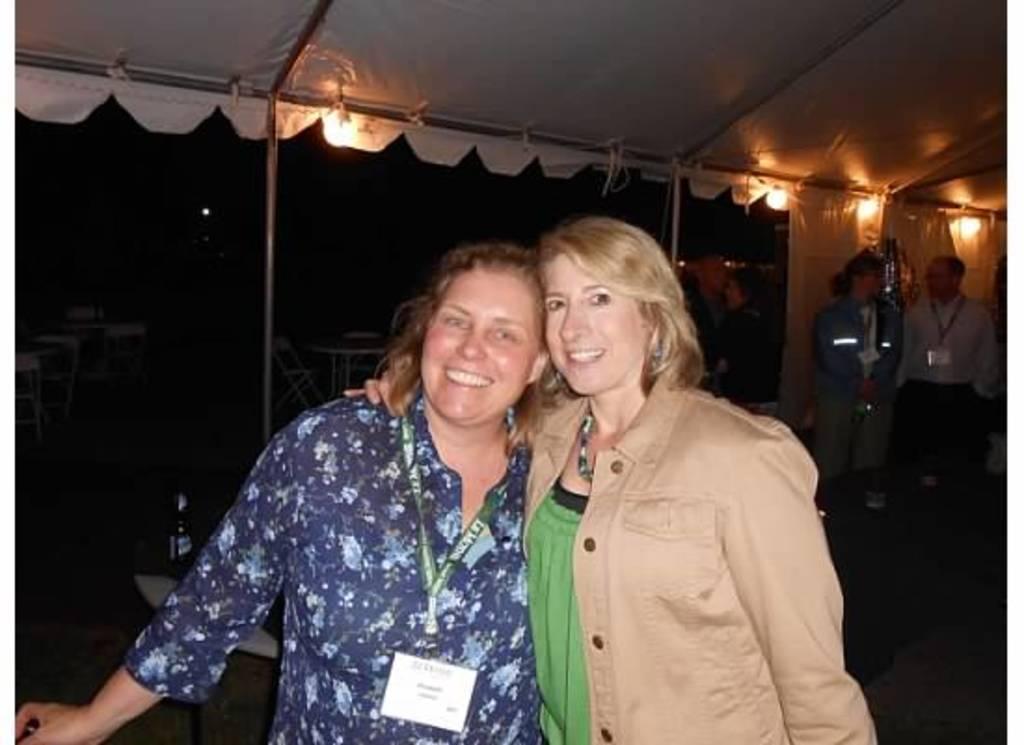How would you summarize this image in a sentence or two? In this image in the center there are two women smiling, and one woman is wearing a tag. And in the background there are some people, poles, tables, chairs and at the top of the image there is a tent. And some lights, and in the background there are some objects. At the bottom there is floor. 